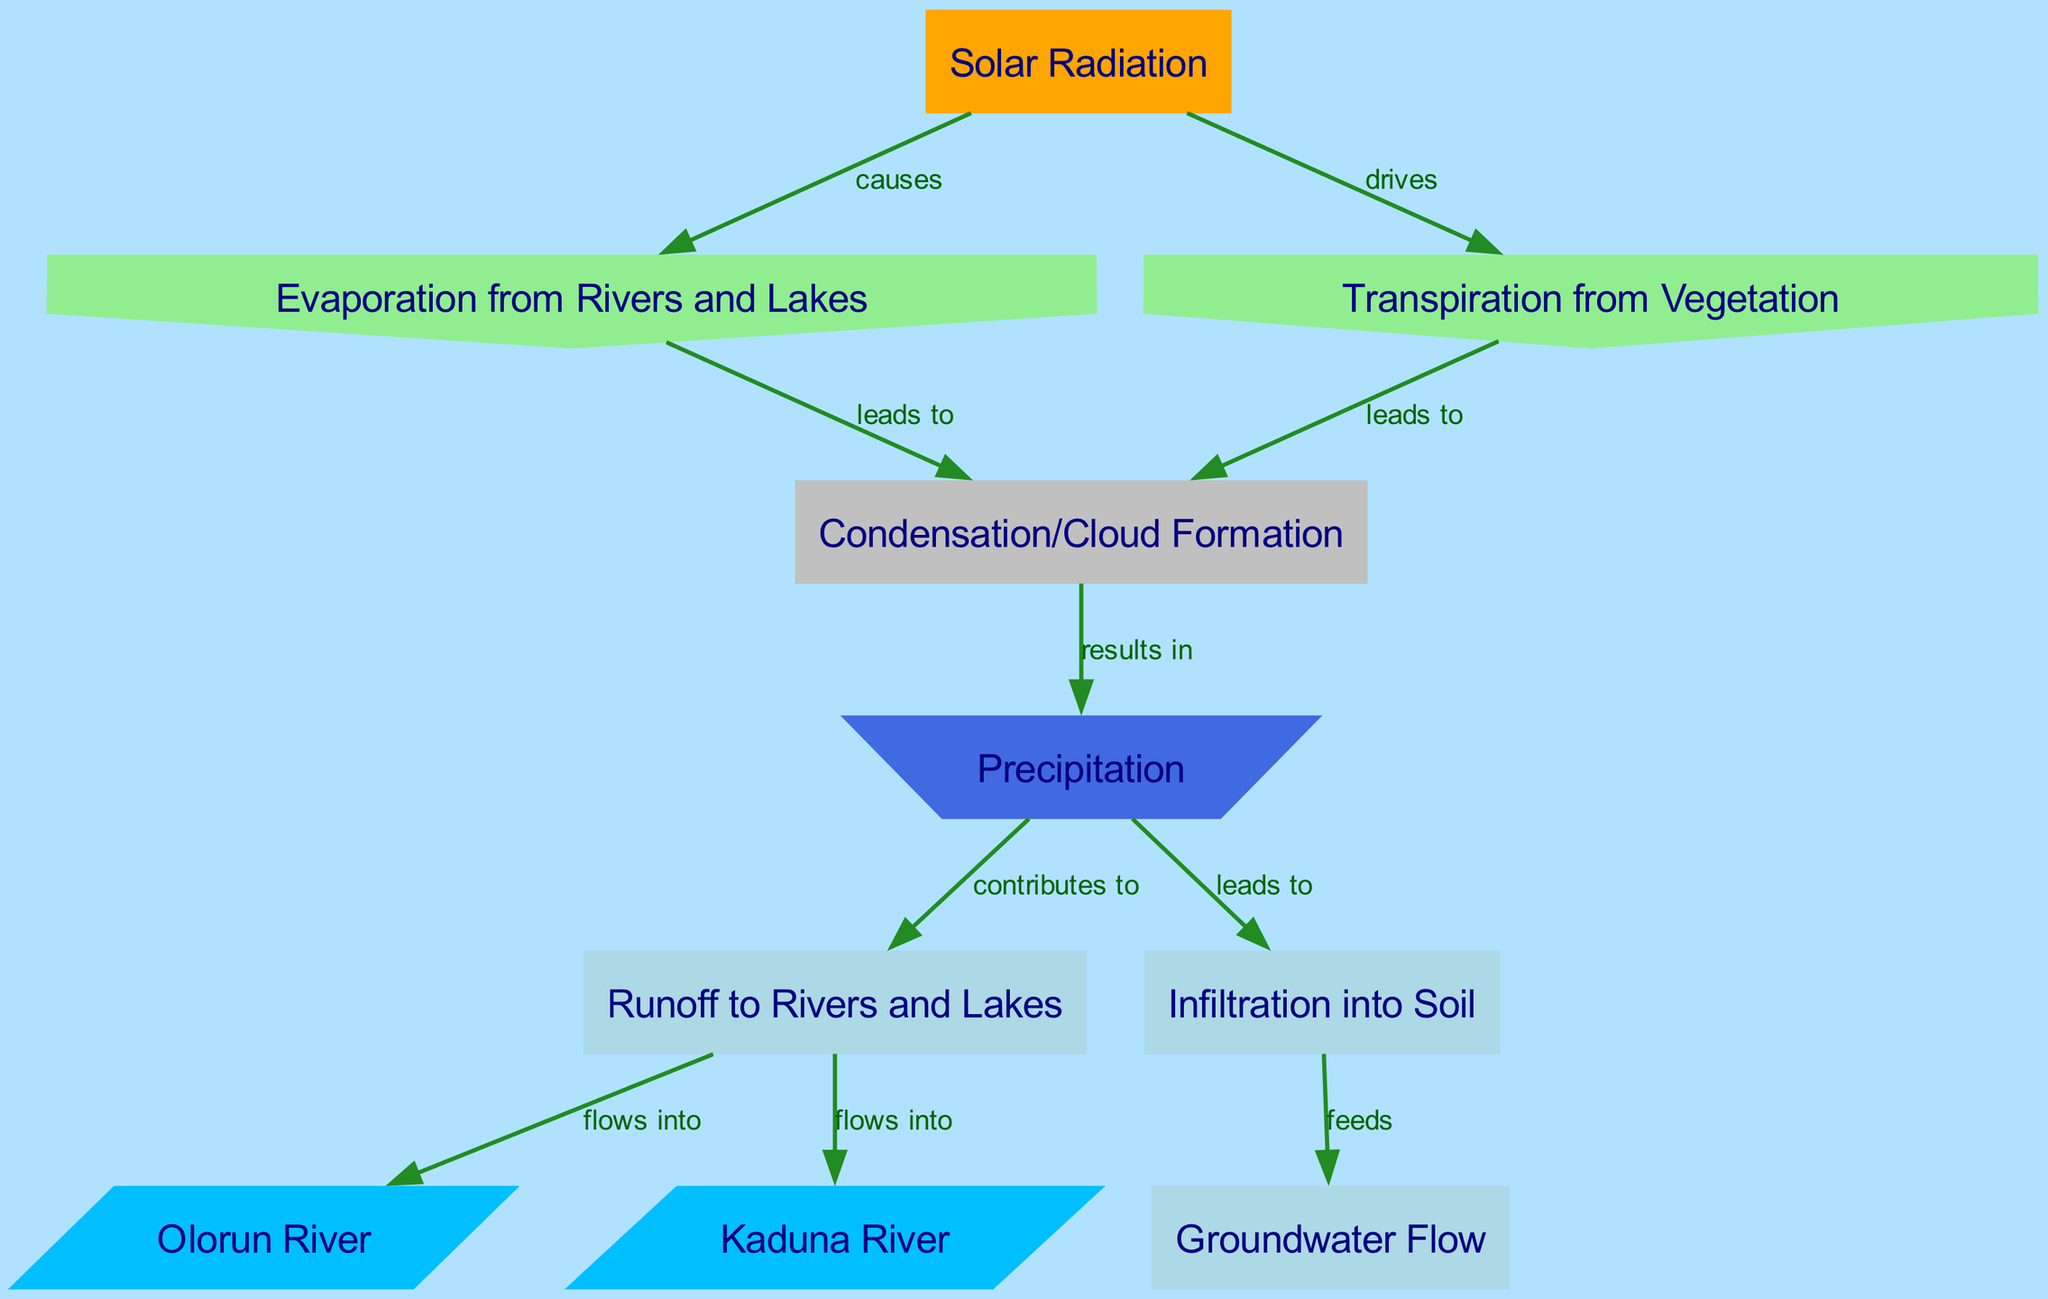what causes evaporation from rivers and lakes? In the diagram, the state labeled "Solar Radiation" is connected to "Evaporation from Rivers and Lakes" with an edge labeled "causes." This indicates that solar radiation is the factor that drives evaporation.
Answer: Solar Radiation how many nodes are in the diagram? The diagram contains a total of 10 nodes, each representing different elements of the water cycle, such as evaporation, condensation, and the rivers.
Answer: 10 which node leads to precipitation? The nodes that lead to "Precipitation" are "Condensation/Cloud Formation," as indicated by the edge labeled "results in." This shows that condensation is the direct precursor to precipitation.
Answer: Condensation/Cloud Formation what contributes to runoff to rivers and lakes? The edge labeled "contributes to" connects "Precipitation" to "Runoff to Rivers and Lakes." This indicates that precipitation aids in the process of runoff.
Answer: Precipitation what is the relationship between infiltration into soil and groundwater flow? The diagram connects "Infiltration into Soil" to "Groundwater Flow" with an edge labeled "feeds." This means that when water infiltrates the soil, it supports the flow of groundwater.
Answer: feeds how does solar radiation affect transpiration from vegetation? The flow diagram indicates that "Solar Radiation" drives "Transpiration from Vegetation," which is shown by the edge labeled "drives." This means that the sun’s energy is essential for the transpiration process to occur.
Answer: drives which rivers are mentioned in the diagram? The diagram specifies two rivers: "Olorun River" and "Kaduna River," which are illustrated as nodes connected by edges showing that runoff flows into them.
Answer: Olorun River and Kaduna River what leads to condensation? The edges from both "Evaporation from Rivers and Lakes" and "Transpiration from Vegetation" show that both these processes lead to "Condensation/Cloud Formation." This indicates that both evaporation and transpiration are necessary for condensation to occur.
Answer: Evaporation from Rivers and Lakes and Transpiration from Vegetation 